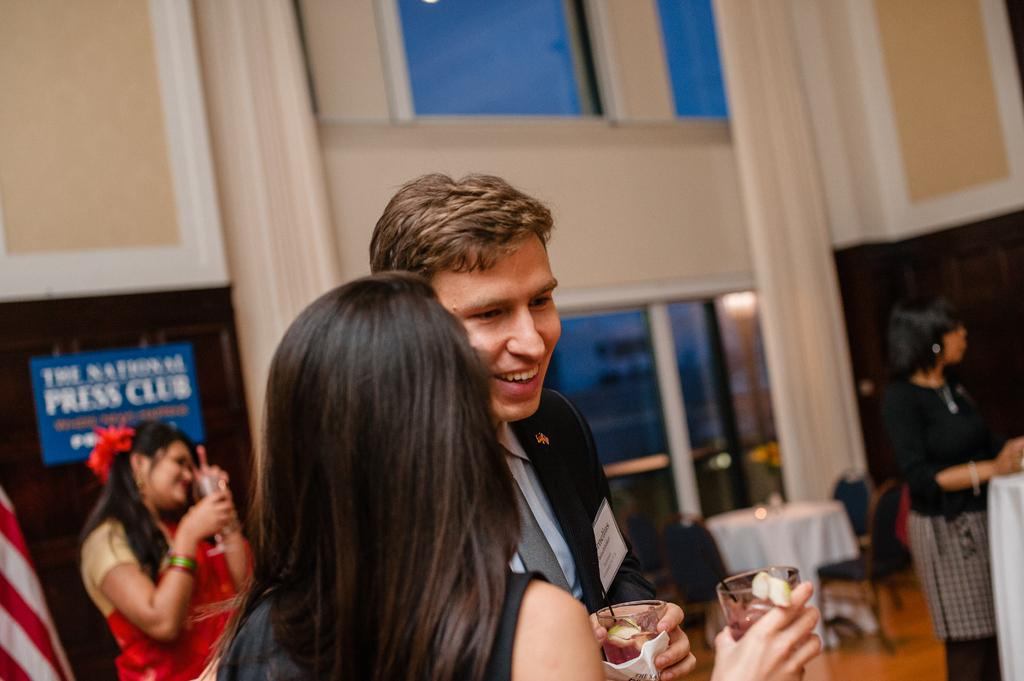How many people are in the image? There are four persons in the image. What are the persons holding in their hands? The persons are holding glasses in their hands. Can you describe the facial expression of one of the persons? One of the persons is smiling. What type of furniture is present in the image? There are tables and chairs in the image. What can be seen in the background of the image? There is a board, glasses, and a wall visible in the background of the image. What type of bun is being served on the table in the image? There is no bun present in the image; the persons are holding glasses, and there are no food items mentioned in the facts. 